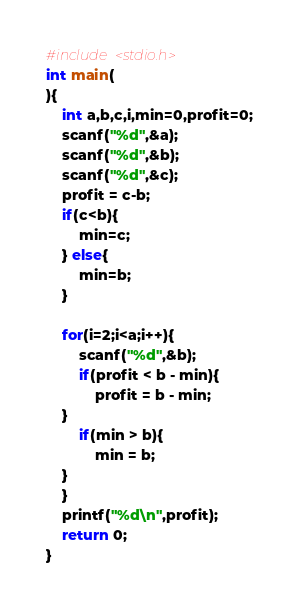Convert code to text. <code><loc_0><loc_0><loc_500><loc_500><_C_>
#include <stdio.h>
int main(
){
    int a,b,c,i,min=0,profit=0;
    scanf("%d",&a);
    scanf("%d",&b);
    scanf("%d",&c);
    profit = c-b;
    if(c<b){
        min=c;
    } else{
        min=b;
    }
    
    for(i=2;i<a;i++){
        scanf("%d",&b);
        if(profit < b - min){
            profit = b - min;
	}
        if(min > b){
            min = b;
	}
    } 
    printf("%d\n",profit);
    return 0;
}

</code> 